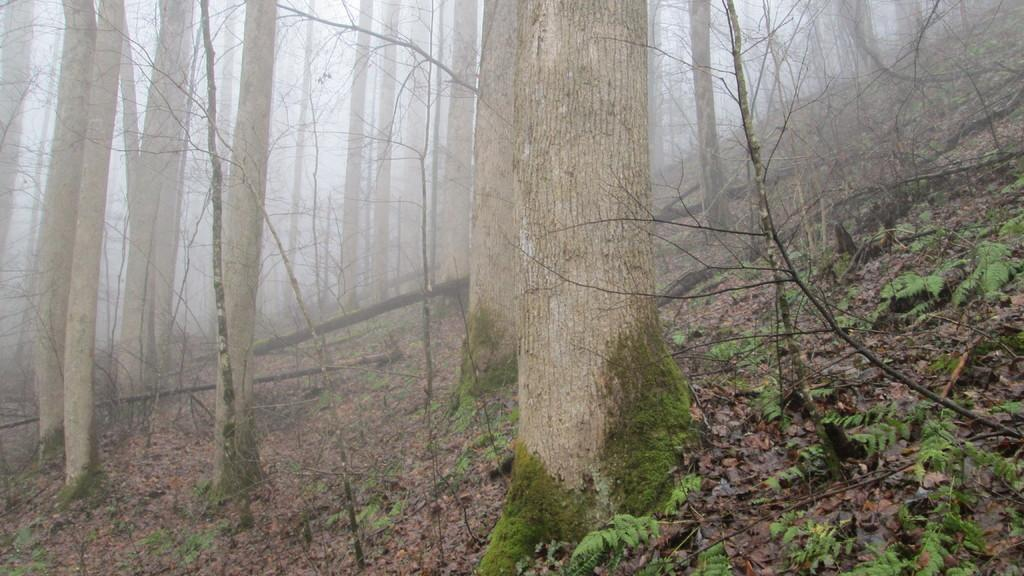What type of vegetation can be seen in the image? There are trees in the image. What atmospheric condition is present in the image? There is fog in the image. What can be found at the bottom of the image? Dry leaves and twigs are visible at the bottom of the image. What type of destruction can be seen in the image? There is no destruction present in the image; it features trees, fog, and dry leaves and twigs. Is there a harbor visible in the image? There is no harbor present in the image. 